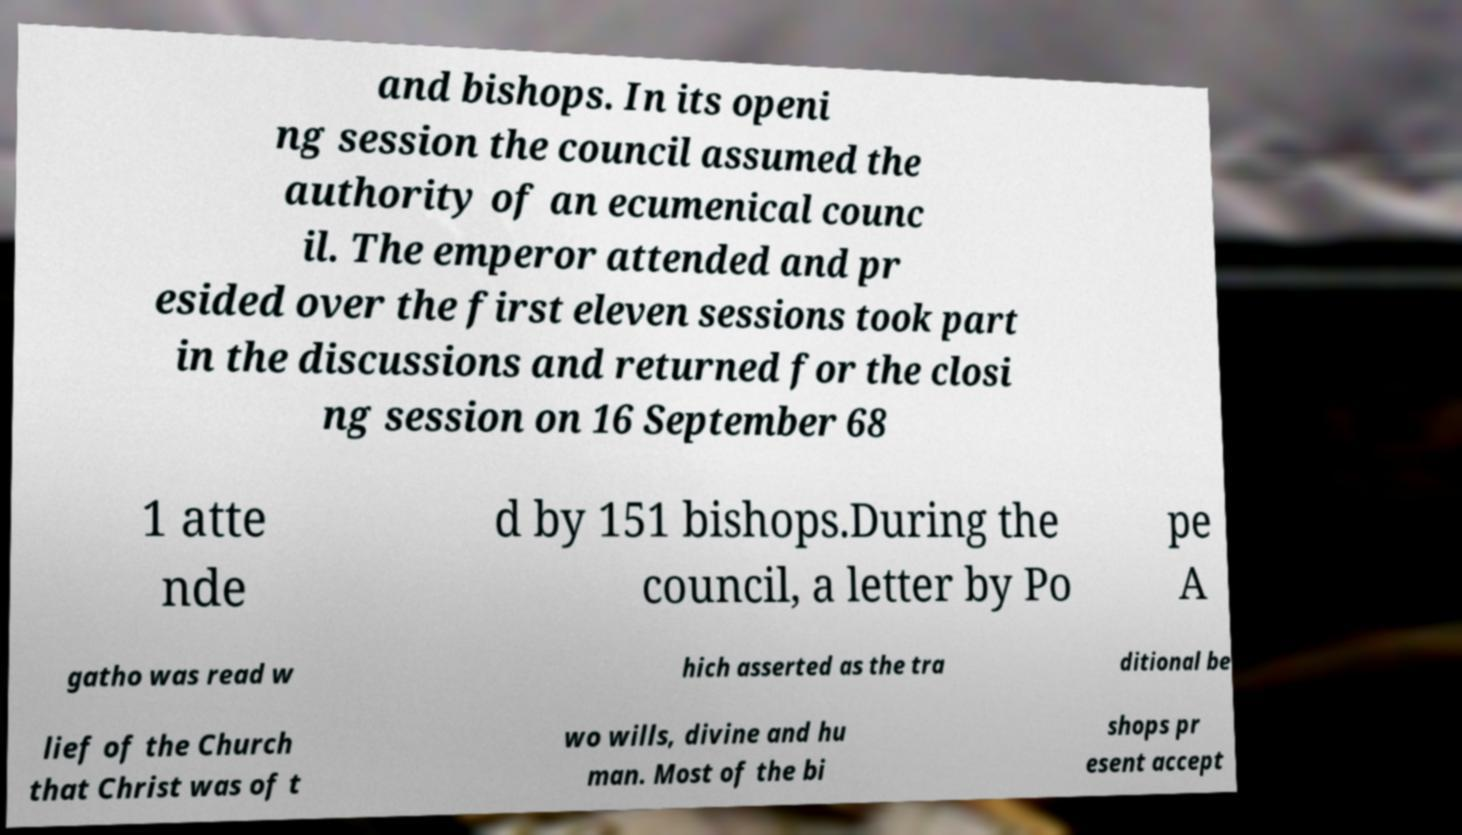What messages or text are displayed in this image? I need them in a readable, typed format. and bishops. In its openi ng session the council assumed the authority of an ecumenical counc il. The emperor attended and pr esided over the first eleven sessions took part in the discussions and returned for the closi ng session on 16 September 68 1 atte nde d by 151 bishops.During the council, a letter by Po pe A gatho was read w hich asserted as the tra ditional be lief of the Church that Christ was of t wo wills, divine and hu man. Most of the bi shops pr esent accept 